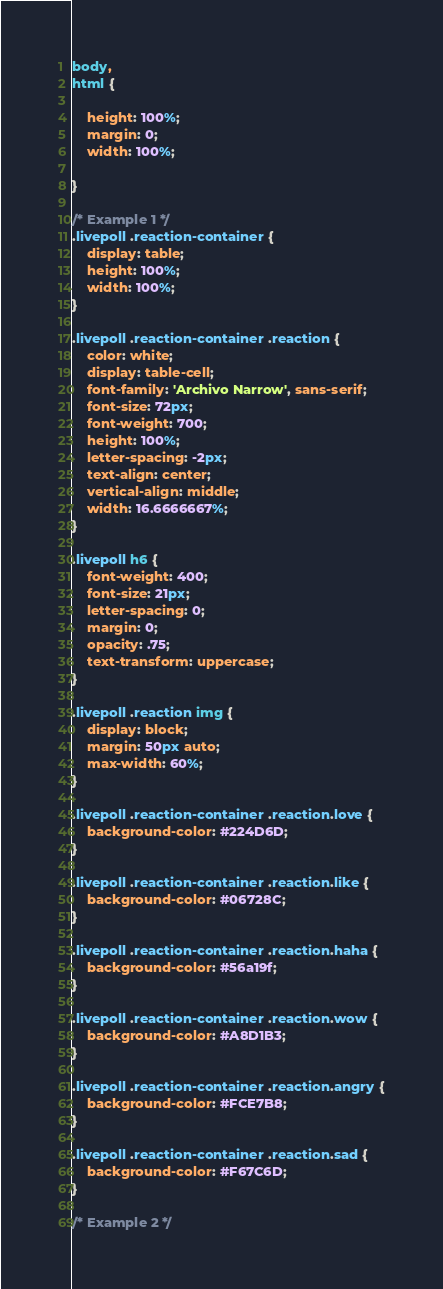Convert code to text. <code><loc_0><loc_0><loc_500><loc_500><_CSS_>body,
html {

	height: 100%;
	margin: 0;
	width: 100%;

}

/* Example 1 */
.livepoll .reaction-container {
	display: table;
	height: 100%;
	width: 100%;
}

.livepoll .reaction-container .reaction {
	color: white;
	display: table-cell;
	font-family: 'Archivo Narrow', sans-serif;
	font-size: 72px;
	font-weight: 700;
	height: 100%;
	letter-spacing: -2px;
	text-align: center;
	vertical-align: middle;
	width: 16.6666667%;
}

.livepoll h6 {
	font-weight: 400;
	font-size: 21px;
	letter-spacing: 0;
	margin: 0;
	opacity: .75;
	text-transform: uppercase;
}

.livepoll .reaction img {
	display: block;
	margin: 50px auto;
	max-width: 60%;
}

.livepoll .reaction-container .reaction.love {
	background-color: #224D6D;
}

.livepoll .reaction-container .reaction.like {
	background-color: #06728C;
}

.livepoll .reaction-container .reaction.haha {
	background-color: #56a19f;
}

.livepoll .reaction-container .reaction.wow {
	background-color: #A8D1B3;
}

.livepoll .reaction-container .reaction.angry {
	background-color: #FCE7B8;
}

.livepoll .reaction-container .reaction.sad {
	background-color: #F67C6D;
}

/* Example 2 */
</code> 